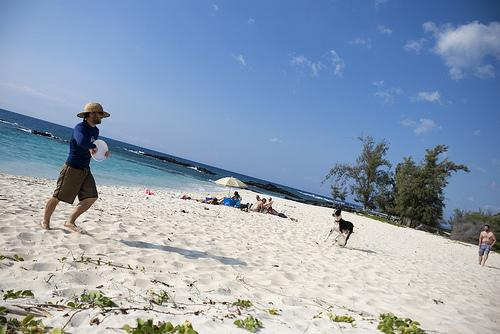Question: why is there an umbrella?
Choices:
A. On the patio.
B. In the backyard.
C. Stay dry from rain.
D. Shade from the sun.
Answer with the letter. Answer: D Question: where is the picture taken?
Choices:
A. Bar.
B. Restaurant.
C. Office.
D. On a beach.
Answer with the letter. Answer: D 